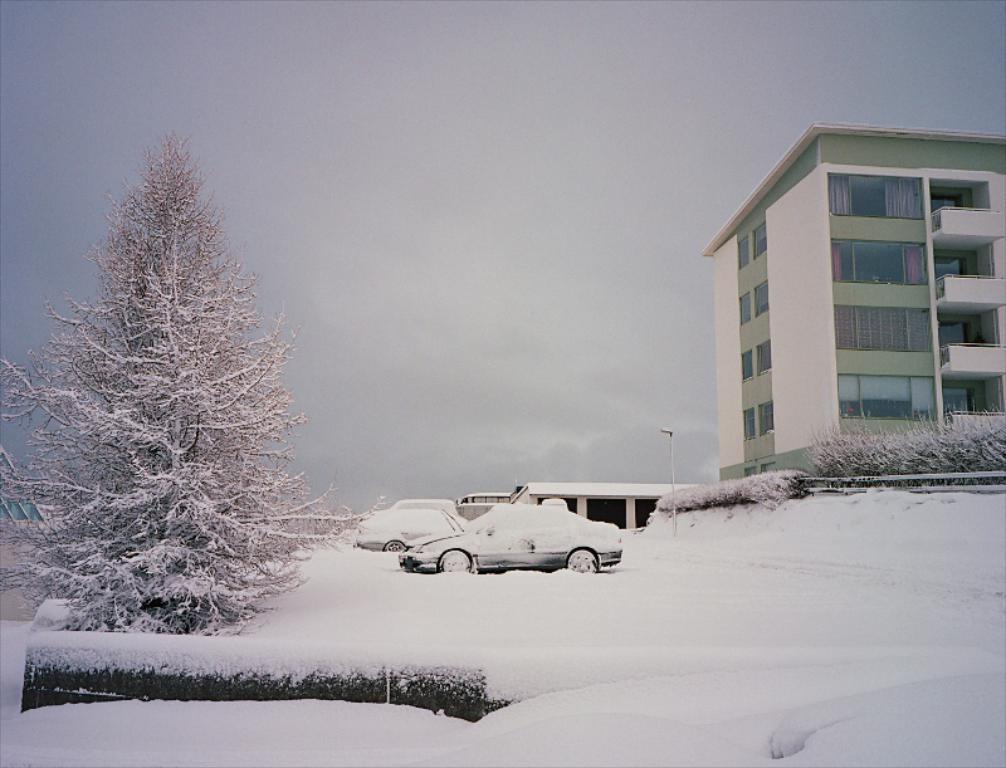In one or two sentences, can you explain what this image depicts? In the picture we can see a snowy surface on it, we can see some cars, tree, building with some glass windows in it and near to the building we can see some plants and in the background we can see a sky. 